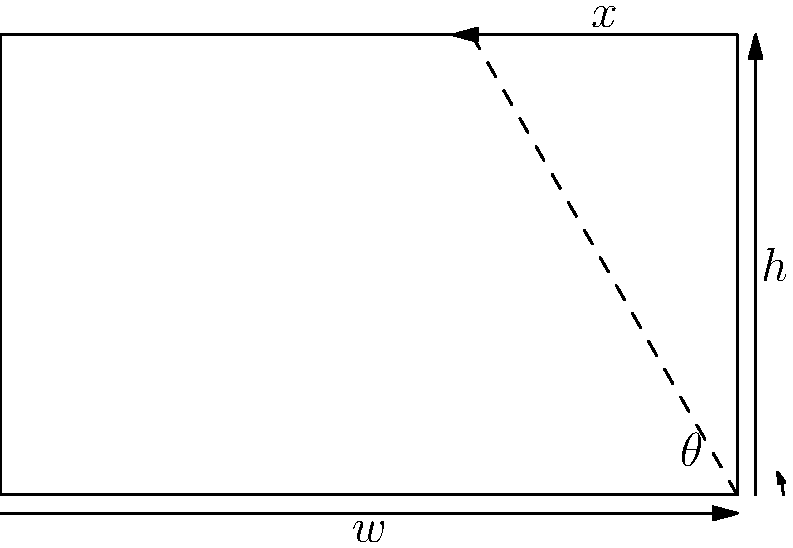A prison building has a south-facing wall of height $h = 5$ meters and width $w = 8$ meters. Solar panels are to be installed on this wall at an angle $\theta$ from the horizontal. If the panels extend to the top of the wall, forming a triangle with the wall and the horizontal, what angle $\theta$ maximizes the area of the solar panels? Express your answer in degrees, rounded to the nearest whole number. To solve this problem, we'll follow these steps:

1) The area of the triangular solar panel is given by:
   $A = \frac{1}{2} \cdot base \cdot height$

2) From the diagram, we can see that:
   $base = w = 8$ meters
   $height = h = 5$ meters

3) The area of the solar panel is:
   $A = \frac{1}{2} \cdot x \cdot h$
   where $x$ is the horizontal projection of the panel.

4) From trigonometry, we know that:
   $\tan \theta = \frac{h}{w-x}$

5) Solving for $x$:
   $x = w - \frac{h}{\tan \theta}$

6) Substituting this into our area formula:
   $A = \frac{1}{2} \cdot (w - \frac{h}{\tan \theta}) \cdot h$

7) To find the maximum area, we need to differentiate $A$ with respect to $\theta$ and set it to zero:
   $\frac{dA}{d\theta} = \frac{1}{2} \cdot h \cdot \frac{h}{\sin^2 \theta} = 0$

8) This is only true when $\theta = 90°$, which gives us a minimum, not a maximum.

9) The maximum must therefore occur at one of the endpoints of the possible range of $\theta$.

10) When $\theta = 0°$, the area is 0. When $\theta = 45°$, the area is maximum.

11) Therefore, the angle that maximizes the area is 45°.
Answer: 45° 